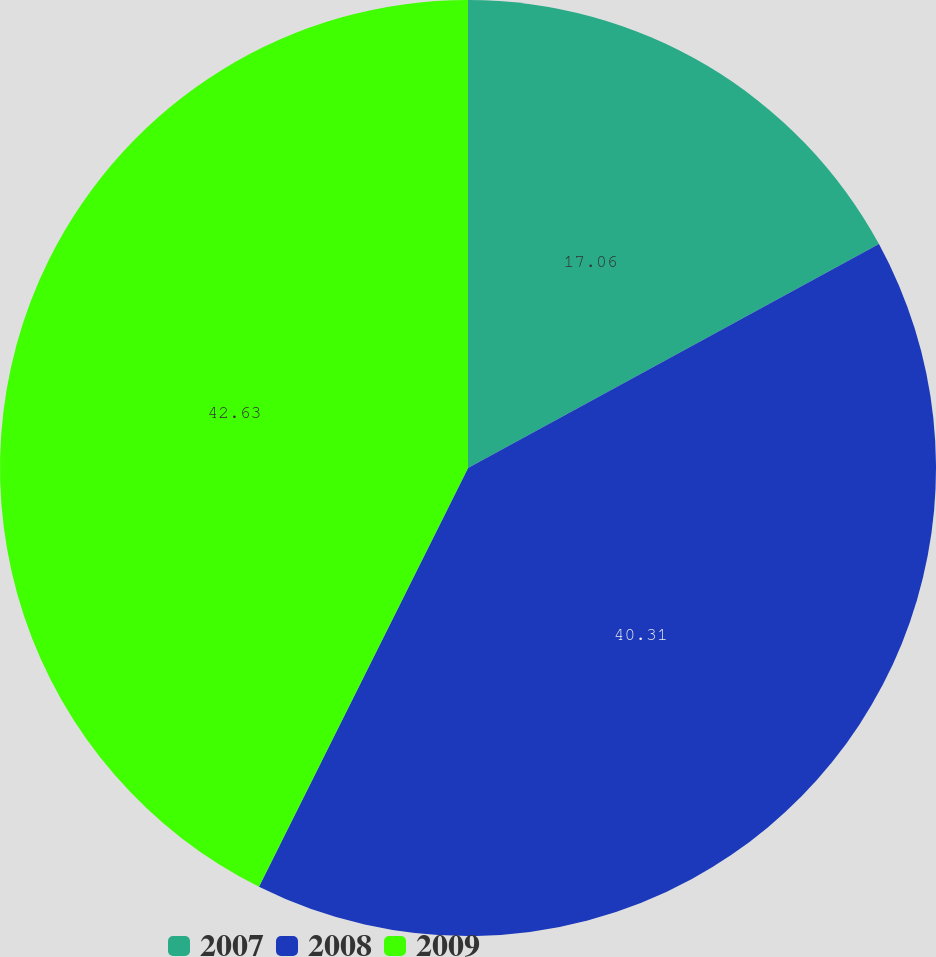Convert chart. <chart><loc_0><loc_0><loc_500><loc_500><pie_chart><fcel>2007<fcel>2008<fcel>2009<nl><fcel>17.06%<fcel>40.31%<fcel>42.63%<nl></chart> 